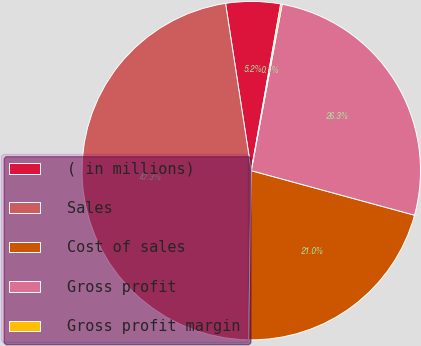Convert chart. <chart><loc_0><loc_0><loc_500><loc_500><pie_chart><fcel>( in millions)<fcel>Sales<fcel>Cost of sales<fcel>Gross profit<fcel>Gross profit margin<nl><fcel>5.21%<fcel>47.32%<fcel>21.01%<fcel>26.32%<fcel>0.14%<nl></chart> 